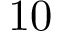Convert formula to latex. <formula><loc_0><loc_0><loc_500><loc_500>1 0</formula> 